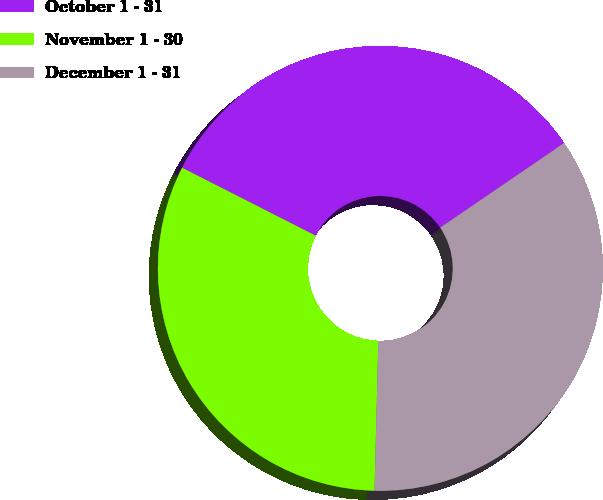Convert chart to OTSL. <chart><loc_0><loc_0><loc_500><loc_500><pie_chart><fcel>October 1 - 31<fcel>November 1 - 30<fcel>December 1 - 31<nl><fcel>32.98%<fcel>32.08%<fcel>34.94%<nl></chart> 